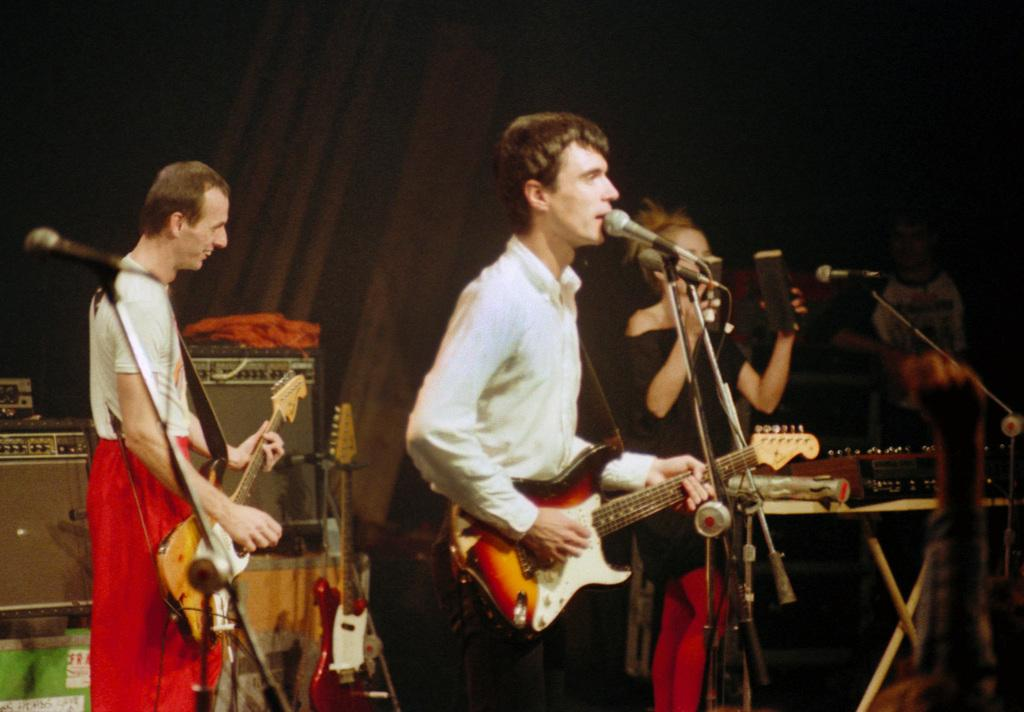How many people are in the image? There is a group of persons in the image. What are the persons in the image doing? The persons are playing musical instruments. Can you tell me how many cherries are on the arm of the grandfather in the image? There is no grandfather or cherry present in the image; it features a group of persons playing musical instruments. 